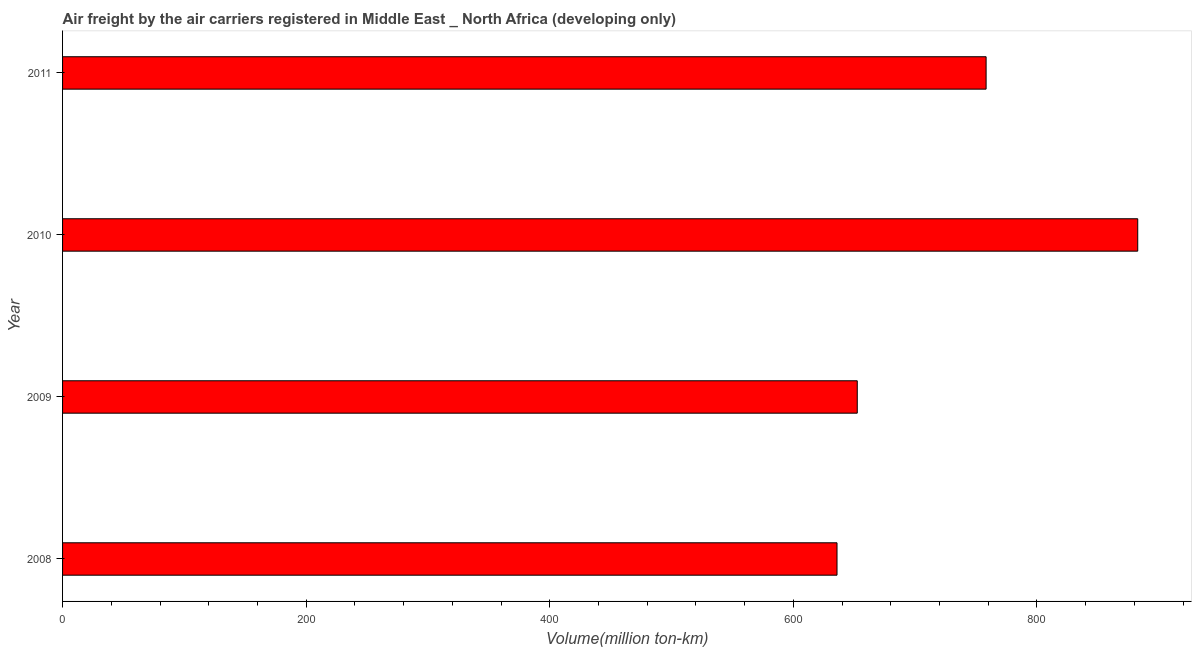Does the graph contain any zero values?
Keep it short and to the point. No. Does the graph contain grids?
Your answer should be very brief. No. What is the title of the graph?
Ensure brevity in your answer.  Air freight by the air carriers registered in Middle East _ North Africa (developing only). What is the label or title of the X-axis?
Your answer should be compact. Volume(million ton-km). What is the label or title of the Y-axis?
Provide a short and direct response. Year. What is the air freight in 2010?
Ensure brevity in your answer.  882.82. Across all years, what is the maximum air freight?
Keep it short and to the point. 882.82. Across all years, what is the minimum air freight?
Your answer should be compact. 635.89. In which year was the air freight maximum?
Offer a terse response. 2010. What is the sum of the air freight?
Offer a very short reply. 2929.54. What is the difference between the air freight in 2009 and 2010?
Your answer should be very brief. -230.29. What is the average air freight per year?
Offer a terse response. 732.39. What is the median air freight?
Provide a succinct answer. 705.42. In how many years, is the air freight greater than 440 million ton-km?
Make the answer very short. 4. What is the ratio of the air freight in 2009 to that in 2011?
Your answer should be very brief. 0.86. Is the difference between the air freight in 2010 and 2011 greater than the difference between any two years?
Make the answer very short. No. What is the difference between the highest and the second highest air freight?
Offer a terse response. 124.5. Is the sum of the air freight in 2008 and 2009 greater than the maximum air freight across all years?
Make the answer very short. Yes. What is the difference between the highest and the lowest air freight?
Your answer should be compact. 246.92. In how many years, is the air freight greater than the average air freight taken over all years?
Offer a terse response. 2. How many years are there in the graph?
Make the answer very short. 4. Are the values on the major ticks of X-axis written in scientific E-notation?
Make the answer very short. No. What is the Volume(million ton-km) in 2008?
Keep it short and to the point. 635.89. What is the Volume(million ton-km) in 2009?
Give a very brief answer. 652.52. What is the Volume(million ton-km) of 2010?
Keep it short and to the point. 882.82. What is the Volume(million ton-km) in 2011?
Offer a very short reply. 758.31. What is the difference between the Volume(million ton-km) in 2008 and 2009?
Your answer should be very brief. -16.63. What is the difference between the Volume(million ton-km) in 2008 and 2010?
Provide a succinct answer. -246.92. What is the difference between the Volume(million ton-km) in 2008 and 2011?
Offer a terse response. -122.42. What is the difference between the Volume(million ton-km) in 2009 and 2010?
Your answer should be compact. -230.29. What is the difference between the Volume(million ton-km) in 2009 and 2011?
Keep it short and to the point. -105.79. What is the difference between the Volume(million ton-km) in 2010 and 2011?
Keep it short and to the point. 124.5. What is the ratio of the Volume(million ton-km) in 2008 to that in 2009?
Keep it short and to the point. 0.97. What is the ratio of the Volume(million ton-km) in 2008 to that in 2010?
Ensure brevity in your answer.  0.72. What is the ratio of the Volume(million ton-km) in 2008 to that in 2011?
Ensure brevity in your answer.  0.84. What is the ratio of the Volume(million ton-km) in 2009 to that in 2010?
Offer a terse response. 0.74. What is the ratio of the Volume(million ton-km) in 2009 to that in 2011?
Ensure brevity in your answer.  0.86. What is the ratio of the Volume(million ton-km) in 2010 to that in 2011?
Ensure brevity in your answer.  1.16. 